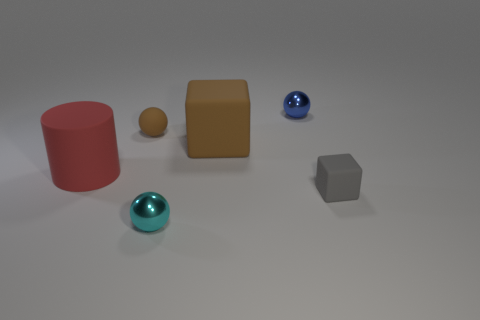The object that is the same color as the small rubber ball is what size?
Give a very brief answer. Large. Are there any other things that are the same size as the blue object?
Offer a very short reply. Yes. Is the gray cube made of the same material as the cylinder?
Make the answer very short. Yes. How many things are either small things that are in front of the large matte cylinder or matte things on the right side of the brown matte cube?
Give a very brief answer. 2. Is there a cyan thing that has the same size as the blue thing?
Your answer should be very brief. Yes. What is the color of the other tiny shiny thing that is the same shape as the small cyan metallic thing?
Keep it short and to the point. Blue. Are there any large red rubber things to the right of the small cyan shiny thing on the left side of the big matte block?
Your answer should be compact. No. Does the big object that is right of the cyan metal ball have the same shape as the gray rubber object?
Offer a very short reply. Yes. There is a large red rubber thing; what shape is it?
Your answer should be compact. Cylinder. How many other gray blocks have the same material as the gray cube?
Offer a very short reply. 0. 